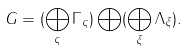<formula> <loc_0><loc_0><loc_500><loc_500>G = ( \bigoplus _ { \varsigma } \Gamma _ { \varsigma } ) \bigoplus ( \bigoplus _ { \xi } \Lambda _ { \xi } ) .</formula> 